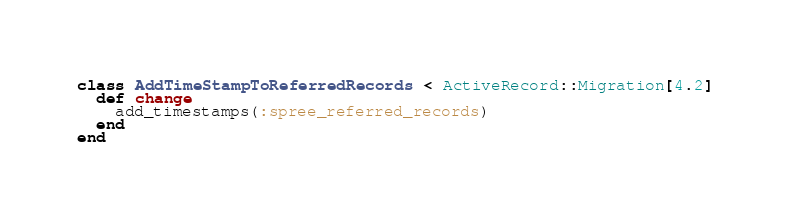<code> <loc_0><loc_0><loc_500><loc_500><_Ruby_>class AddTimeStampToReferredRecords < ActiveRecord::Migration[4.2]
  def change
    add_timestamps(:spree_referred_records)
  end
end
</code> 